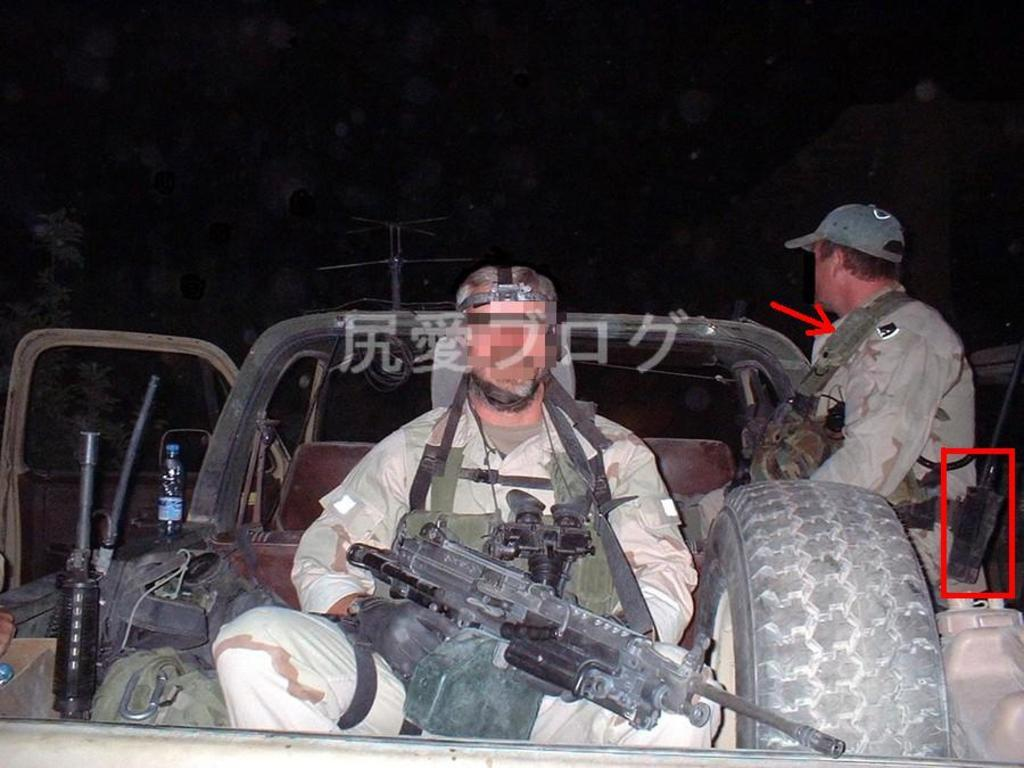How many people are in the vehicle in the image? There are two people sitting in the vehicle in the image. What is one of the people holding? One person is holding a gun. What object is beside the person holding the gun? There is a tire beside the person holding the gun. What can be seen in the background of the image? There is a tree and a pole in the background of the image. How would you describe the lighting in the image? The image appears to be dark. How many kittens are playing on the pole in the image? There are no kittens present in the image; the pole is in the background without any animals. What type of glove is the person wearing while holding the gun? The image does not show the person wearing any gloves, so it cannot be determined from the image. 